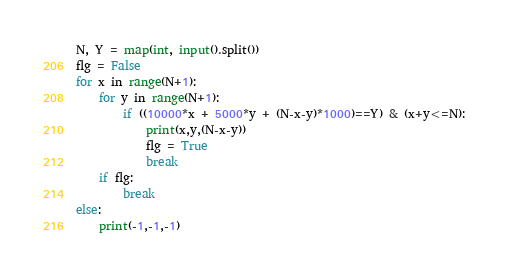<code> <loc_0><loc_0><loc_500><loc_500><_Python_>N, Y = map(int, input().split())
flg = False
for x in range(N+1):
    for y in range(N+1):
        if ((10000*x + 5000*y + (N-x-y)*1000)==Y) & (x+y<=N):
            print(x,y,(N-x-y))
            flg = True
            break
    if flg:
        break
else:
    print(-1,-1,-1)

</code> 